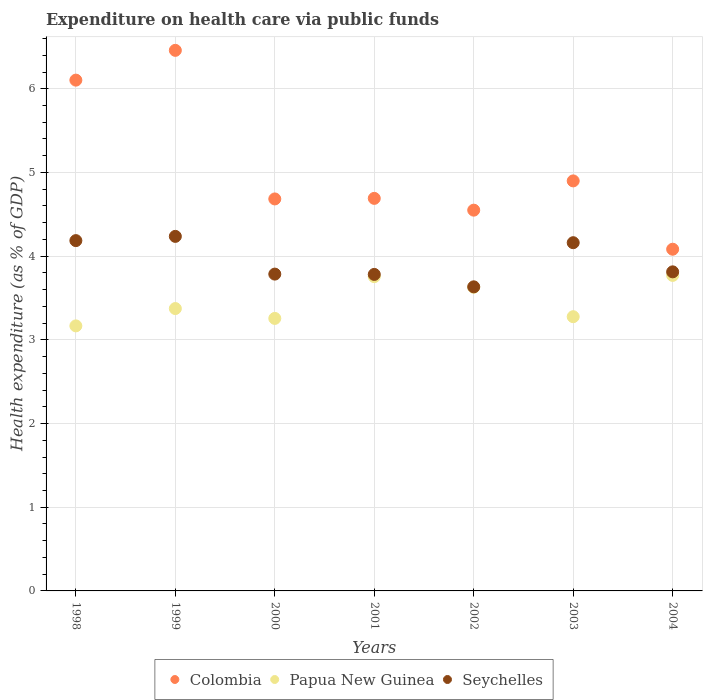How many different coloured dotlines are there?
Your response must be concise. 3. What is the expenditure made on health care in Papua New Guinea in 2004?
Your response must be concise. 3.77. Across all years, what is the maximum expenditure made on health care in Papua New Guinea?
Offer a very short reply. 3.77. Across all years, what is the minimum expenditure made on health care in Colombia?
Keep it short and to the point. 4.08. What is the total expenditure made on health care in Papua New Guinea in the graph?
Your response must be concise. 24.23. What is the difference between the expenditure made on health care in Papua New Guinea in 2002 and that in 2003?
Provide a succinct answer. 0.35. What is the difference between the expenditure made on health care in Papua New Guinea in 2003 and the expenditure made on health care in Colombia in 1999?
Your answer should be compact. -3.18. What is the average expenditure made on health care in Colombia per year?
Your answer should be compact. 5.07. In the year 2003, what is the difference between the expenditure made on health care in Papua New Guinea and expenditure made on health care in Colombia?
Your answer should be very brief. -1.62. In how many years, is the expenditure made on health care in Papua New Guinea greater than 3.8 %?
Your answer should be compact. 0. What is the ratio of the expenditure made on health care in Seychelles in 1999 to that in 2001?
Give a very brief answer. 1.12. What is the difference between the highest and the second highest expenditure made on health care in Seychelles?
Ensure brevity in your answer.  0.05. What is the difference between the highest and the lowest expenditure made on health care in Papua New Guinea?
Provide a short and direct response. 0.6. Is the sum of the expenditure made on health care in Papua New Guinea in 1998 and 2002 greater than the maximum expenditure made on health care in Seychelles across all years?
Keep it short and to the point. Yes. Is it the case that in every year, the sum of the expenditure made on health care in Colombia and expenditure made on health care in Papua New Guinea  is greater than the expenditure made on health care in Seychelles?
Your answer should be very brief. Yes. Is the expenditure made on health care in Papua New Guinea strictly less than the expenditure made on health care in Colombia over the years?
Your response must be concise. Yes. How many dotlines are there?
Your answer should be compact. 3. What is the difference between two consecutive major ticks on the Y-axis?
Make the answer very short. 1. Are the values on the major ticks of Y-axis written in scientific E-notation?
Make the answer very short. No. How are the legend labels stacked?
Provide a succinct answer. Horizontal. What is the title of the graph?
Make the answer very short. Expenditure on health care via public funds. What is the label or title of the X-axis?
Ensure brevity in your answer.  Years. What is the label or title of the Y-axis?
Provide a succinct answer. Health expenditure (as % of GDP). What is the Health expenditure (as % of GDP) of Colombia in 1998?
Ensure brevity in your answer.  6.1. What is the Health expenditure (as % of GDP) in Papua New Guinea in 1998?
Provide a short and direct response. 3.17. What is the Health expenditure (as % of GDP) of Seychelles in 1998?
Keep it short and to the point. 4.19. What is the Health expenditure (as % of GDP) in Colombia in 1999?
Offer a terse response. 6.46. What is the Health expenditure (as % of GDP) of Papua New Guinea in 1999?
Offer a terse response. 3.37. What is the Health expenditure (as % of GDP) in Seychelles in 1999?
Your response must be concise. 4.24. What is the Health expenditure (as % of GDP) of Colombia in 2000?
Keep it short and to the point. 4.68. What is the Health expenditure (as % of GDP) in Papua New Guinea in 2000?
Keep it short and to the point. 3.26. What is the Health expenditure (as % of GDP) in Seychelles in 2000?
Your answer should be compact. 3.79. What is the Health expenditure (as % of GDP) of Colombia in 2001?
Keep it short and to the point. 4.69. What is the Health expenditure (as % of GDP) of Papua New Guinea in 2001?
Provide a short and direct response. 3.76. What is the Health expenditure (as % of GDP) of Seychelles in 2001?
Your answer should be compact. 3.78. What is the Health expenditure (as % of GDP) in Colombia in 2002?
Make the answer very short. 4.55. What is the Health expenditure (as % of GDP) in Papua New Guinea in 2002?
Keep it short and to the point. 3.63. What is the Health expenditure (as % of GDP) of Seychelles in 2002?
Your response must be concise. 3.63. What is the Health expenditure (as % of GDP) in Colombia in 2003?
Your answer should be very brief. 4.9. What is the Health expenditure (as % of GDP) in Papua New Guinea in 2003?
Provide a succinct answer. 3.28. What is the Health expenditure (as % of GDP) in Seychelles in 2003?
Provide a succinct answer. 4.16. What is the Health expenditure (as % of GDP) of Colombia in 2004?
Your response must be concise. 4.08. What is the Health expenditure (as % of GDP) in Papua New Guinea in 2004?
Make the answer very short. 3.77. What is the Health expenditure (as % of GDP) of Seychelles in 2004?
Keep it short and to the point. 3.81. Across all years, what is the maximum Health expenditure (as % of GDP) of Colombia?
Ensure brevity in your answer.  6.46. Across all years, what is the maximum Health expenditure (as % of GDP) in Papua New Guinea?
Your response must be concise. 3.77. Across all years, what is the maximum Health expenditure (as % of GDP) of Seychelles?
Give a very brief answer. 4.24. Across all years, what is the minimum Health expenditure (as % of GDP) of Colombia?
Ensure brevity in your answer.  4.08. Across all years, what is the minimum Health expenditure (as % of GDP) of Papua New Guinea?
Provide a succinct answer. 3.17. Across all years, what is the minimum Health expenditure (as % of GDP) of Seychelles?
Provide a succinct answer. 3.63. What is the total Health expenditure (as % of GDP) in Colombia in the graph?
Provide a short and direct response. 35.47. What is the total Health expenditure (as % of GDP) in Papua New Guinea in the graph?
Your response must be concise. 24.23. What is the total Health expenditure (as % of GDP) of Seychelles in the graph?
Provide a short and direct response. 27.6. What is the difference between the Health expenditure (as % of GDP) in Colombia in 1998 and that in 1999?
Offer a very short reply. -0.36. What is the difference between the Health expenditure (as % of GDP) in Papua New Guinea in 1998 and that in 1999?
Your answer should be compact. -0.21. What is the difference between the Health expenditure (as % of GDP) in Seychelles in 1998 and that in 1999?
Give a very brief answer. -0.05. What is the difference between the Health expenditure (as % of GDP) of Colombia in 1998 and that in 2000?
Make the answer very short. 1.42. What is the difference between the Health expenditure (as % of GDP) of Papua New Guinea in 1998 and that in 2000?
Provide a succinct answer. -0.09. What is the difference between the Health expenditure (as % of GDP) of Seychelles in 1998 and that in 2000?
Your answer should be compact. 0.4. What is the difference between the Health expenditure (as % of GDP) of Colombia in 1998 and that in 2001?
Make the answer very short. 1.41. What is the difference between the Health expenditure (as % of GDP) of Papua New Guinea in 1998 and that in 2001?
Provide a succinct answer. -0.59. What is the difference between the Health expenditure (as % of GDP) of Seychelles in 1998 and that in 2001?
Your answer should be very brief. 0.4. What is the difference between the Health expenditure (as % of GDP) of Colombia in 1998 and that in 2002?
Make the answer very short. 1.55. What is the difference between the Health expenditure (as % of GDP) of Papua New Guinea in 1998 and that in 2002?
Provide a short and direct response. -0.46. What is the difference between the Health expenditure (as % of GDP) in Seychelles in 1998 and that in 2002?
Ensure brevity in your answer.  0.55. What is the difference between the Health expenditure (as % of GDP) of Colombia in 1998 and that in 2003?
Provide a short and direct response. 1.2. What is the difference between the Health expenditure (as % of GDP) in Papua New Guinea in 1998 and that in 2003?
Your response must be concise. -0.11. What is the difference between the Health expenditure (as % of GDP) of Seychelles in 1998 and that in 2003?
Your response must be concise. 0.02. What is the difference between the Health expenditure (as % of GDP) of Colombia in 1998 and that in 2004?
Your answer should be very brief. 2.02. What is the difference between the Health expenditure (as % of GDP) of Papua New Guinea in 1998 and that in 2004?
Your answer should be compact. -0.6. What is the difference between the Health expenditure (as % of GDP) in Seychelles in 1998 and that in 2004?
Provide a short and direct response. 0.37. What is the difference between the Health expenditure (as % of GDP) of Colombia in 1999 and that in 2000?
Your answer should be compact. 1.78. What is the difference between the Health expenditure (as % of GDP) in Papua New Guinea in 1999 and that in 2000?
Your answer should be compact. 0.12. What is the difference between the Health expenditure (as % of GDP) in Seychelles in 1999 and that in 2000?
Offer a terse response. 0.45. What is the difference between the Health expenditure (as % of GDP) of Colombia in 1999 and that in 2001?
Your response must be concise. 1.77. What is the difference between the Health expenditure (as % of GDP) in Papua New Guinea in 1999 and that in 2001?
Offer a terse response. -0.38. What is the difference between the Health expenditure (as % of GDP) in Seychelles in 1999 and that in 2001?
Your answer should be compact. 0.45. What is the difference between the Health expenditure (as % of GDP) of Colombia in 1999 and that in 2002?
Offer a very short reply. 1.91. What is the difference between the Health expenditure (as % of GDP) in Papua New Guinea in 1999 and that in 2002?
Keep it short and to the point. -0.25. What is the difference between the Health expenditure (as % of GDP) in Seychelles in 1999 and that in 2002?
Keep it short and to the point. 0.6. What is the difference between the Health expenditure (as % of GDP) in Colombia in 1999 and that in 2003?
Your answer should be very brief. 1.56. What is the difference between the Health expenditure (as % of GDP) of Papua New Guinea in 1999 and that in 2003?
Offer a terse response. 0.1. What is the difference between the Health expenditure (as % of GDP) of Seychelles in 1999 and that in 2003?
Give a very brief answer. 0.08. What is the difference between the Health expenditure (as % of GDP) in Colombia in 1999 and that in 2004?
Make the answer very short. 2.38. What is the difference between the Health expenditure (as % of GDP) in Papua New Guinea in 1999 and that in 2004?
Keep it short and to the point. -0.4. What is the difference between the Health expenditure (as % of GDP) of Seychelles in 1999 and that in 2004?
Ensure brevity in your answer.  0.42. What is the difference between the Health expenditure (as % of GDP) in Colombia in 2000 and that in 2001?
Provide a succinct answer. -0.01. What is the difference between the Health expenditure (as % of GDP) in Papua New Guinea in 2000 and that in 2001?
Provide a short and direct response. -0.5. What is the difference between the Health expenditure (as % of GDP) of Seychelles in 2000 and that in 2001?
Your response must be concise. 0. What is the difference between the Health expenditure (as % of GDP) of Colombia in 2000 and that in 2002?
Offer a very short reply. 0.13. What is the difference between the Health expenditure (as % of GDP) of Papua New Guinea in 2000 and that in 2002?
Offer a terse response. -0.37. What is the difference between the Health expenditure (as % of GDP) in Seychelles in 2000 and that in 2002?
Provide a short and direct response. 0.15. What is the difference between the Health expenditure (as % of GDP) of Colombia in 2000 and that in 2003?
Offer a very short reply. -0.22. What is the difference between the Health expenditure (as % of GDP) in Papua New Guinea in 2000 and that in 2003?
Provide a short and direct response. -0.02. What is the difference between the Health expenditure (as % of GDP) in Seychelles in 2000 and that in 2003?
Offer a terse response. -0.38. What is the difference between the Health expenditure (as % of GDP) of Colombia in 2000 and that in 2004?
Ensure brevity in your answer.  0.6. What is the difference between the Health expenditure (as % of GDP) of Papua New Guinea in 2000 and that in 2004?
Your answer should be compact. -0.51. What is the difference between the Health expenditure (as % of GDP) in Seychelles in 2000 and that in 2004?
Keep it short and to the point. -0.03. What is the difference between the Health expenditure (as % of GDP) of Colombia in 2001 and that in 2002?
Your response must be concise. 0.14. What is the difference between the Health expenditure (as % of GDP) in Papua New Guinea in 2001 and that in 2002?
Your answer should be very brief. 0.13. What is the difference between the Health expenditure (as % of GDP) in Seychelles in 2001 and that in 2002?
Provide a short and direct response. 0.15. What is the difference between the Health expenditure (as % of GDP) of Colombia in 2001 and that in 2003?
Your answer should be compact. -0.21. What is the difference between the Health expenditure (as % of GDP) of Papua New Guinea in 2001 and that in 2003?
Your response must be concise. 0.48. What is the difference between the Health expenditure (as % of GDP) in Seychelles in 2001 and that in 2003?
Give a very brief answer. -0.38. What is the difference between the Health expenditure (as % of GDP) of Colombia in 2001 and that in 2004?
Provide a succinct answer. 0.61. What is the difference between the Health expenditure (as % of GDP) in Papua New Guinea in 2001 and that in 2004?
Your answer should be compact. -0.01. What is the difference between the Health expenditure (as % of GDP) of Seychelles in 2001 and that in 2004?
Keep it short and to the point. -0.03. What is the difference between the Health expenditure (as % of GDP) of Colombia in 2002 and that in 2003?
Your answer should be compact. -0.35. What is the difference between the Health expenditure (as % of GDP) in Papua New Guinea in 2002 and that in 2003?
Offer a terse response. 0.35. What is the difference between the Health expenditure (as % of GDP) in Seychelles in 2002 and that in 2003?
Provide a short and direct response. -0.53. What is the difference between the Health expenditure (as % of GDP) in Colombia in 2002 and that in 2004?
Offer a terse response. 0.47. What is the difference between the Health expenditure (as % of GDP) in Papua New Guinea in 2002 and that in 2004?
Your response must be concise. -0.14. What is the difference between the Health expenditure (as % of GDP) in Seychelles in 2002 and that in 2004?
Provide a succinct answer. -0.18. What is the difference between the Health expenditure (as % of GDP) in Colombia in 2003 and that in 2004?
Provide a short and direct response. 0.82. What is the difference between the Health expenditure (as % of GDP) of Papua New Guinea in 2003 and that in 2004?
Keep it short and to the point. -0.49. What is the difference between the Health expenditure (as % of GDP) of Seychelles in 2003 and that in 2004?
Provide a short and direct response. 0.35. What is the difference between the Health expenditure (as % of GDP) of Colombia in 1998 and the Health expenditure (as % of GDP) of Papua New Guinea in 1999?
Offer a terse response. 2.73. What is the difference between the Health expenditure (as % of GDP) of Colombia in 1998 and the Health expenditure (as % of GDP) of Seychelles in 1999?
Offer a terse response. 1.87. What is the difference between the Health expenditure (as % of GDP) of Papua New Guinea in 1998 and the Health expenditure (as % of GDP) of Seychelles in 1999?
Provide a succinct answer. -1.07. What is the difference between the Health expenditure (as % of GDP) in Colombia in 1998 and the Health expenditure (as % of GDP) in Papua New Guinea in 2000?
Offer a very short reply. 2.85. What is the difference between the Health expenditure (as % of GDP) of Colombia in 1998 and the Health expenditure (as % of GDP) of Seychelles in 2000?
Provide a succinct answer. 2.32. What is the difference between the Health expenditure (as % of GDP) of Papua New Guinea in 1998 and the Health expenditure (as % of GDP) of Seychelles in 2000?
Offer a terse response. -0.62. What is the difference between the Health expenditure (as % of GDP) in Colombia in 1998 and the Health expenditure (as % of GDP) in Papua New Guinea in 2001?
Give a very brief answer. 2.35. What is the difference between the Health expenditure (as % of GDP) of Colombia in 1998 and the Health expenditure (as % of GDP) of Seychelles in 2001?
Offer a terse response. 2.32. What is the difference between the Health expenditure (as % of GDP) of Papua New Guinea in 1998 and the Health expenditure (as % of GDP) of Seychelles in 2001?
Ensure brevity in your answer.  -0.61. What is the difference between the Health expenditure (as % of GDP) in Colombia in 1998 and the Health expenditure (as % of GDP) in Papua New Guinea in 2002?
Ensure brevity in your answer.  2.48. What is the difference between the Health expenditure (as % of GDP) in Colombia in 1998 and the Health expenditure (as % of GDP) in Seychelles in 2002?
Ensure brevity in your answer.  2.47. What is the difference between the Health expenditure (as % of GDP) in Papua New Guinea in 1998 and the Health expenditure (as % of GDP) in Seychelles in 2002?
Your response must be concise. -0.47. What is the difference between the Health expenditure (as % of GDP) of Colombia in 1998 and the Health expenditure (as % of GDP) of Papua New Guinea in 2003?
Make the answer very short. 2.83. What is the difference between the Health expenditure (as % of GDP) in Colombia in 1998 and the Health expenditure (as % of GDP) in Seychelles in 2003?
Provide a short and direct response. 1.94. What is the difference between the Health expenditure (as % of GDP) in Papua New Guinea in 1998 and the Health expenditure (as % of GDP) in Seychelles in 2003?
Your answer should be very brief. -0.99. What is the difference between the Health expenditure (as % of GDP) of Colombia in 1998 and the Health expenditure (as % of GDP) of Papua New Guinea in 2004?
Ensure brevity in your answer.  2.33. What is the difference between the Health expenditure (as % of GDP) of Colombia in 1998 and the Health expenditure (as % of GDP) of Seychelles in 2004?
Ensure brevity in your answer.  2.29. What is the difference between the Health expenditure (as % of GDP) of Papua New Guinea in 1998 and the Health expenditure (as % of GDP) of Seychelles in 2004?
Offer a very short reply. -0.65. What is the difference between the Health expenditure (as % of GDP) in Colombia in 1999 and the Health expenditure (as % of GDP) in Papua New Guinea in 2000?
Make the answer very short. 3.2. What is the difference between the Health expenditure (as % of GDP) of Colombia in 1999 and the Health expenditure (as % of GDP) of Seychelles in 2000?
Your response must be concise. 2.67. What is the difference between the Health expenditure (as % of GDP) in Papua New Guinea in 1999 and the Health expenditure (as % of GDP) in Seychelles in 2000?
Offer a terse response. -0.41. What is the difference between the Health expenditure (as % of GDP) of Colombia in 1999 and the Health expenditure (as % of GDP) of Papua New Guinea in 2001?
Your answer should be very brief. 2.7. What is the difference between the Health expenditure (as % of GDP) of Colombia in 1999 and the Health expenditure (as % of GDP) of Seychelles in 2001?
Offer a very short reply. 2.68. What is the difference between the Health expenditure (as % of GDP) of Papua New Guinea in 1999 and the Health expenditure (as % of GDP) of Seychelles in 2001?
Give a very brief answer. -0.41. What is the difference between the Health expenditure (as % of GDP) in Colombia in 1999 and the Health expenditure (as % of GDP) in Papua New Guinea in 2002?
Your response must be concise. 2.83. What is the difference between the Health expenditure (as % of GDP) in Colombia in 1999 and the Health expenditure (as % of GDP) in Seychelles in 2002?
Make the answer very short. 2.83. What is the difference between the Health expenditure (as % of GDP) in Papua New Guinea in 1999 and the Health expenditure (as % of GDP) in Seychelles in 2002?
Offer a very short reply. -0.26. What is the difference between the Health expenditure (as % of GDP) in Colombia in 1999 and the Health expenditure (as % of GDP) in Papua New Guinea in 2003?
Make the answer very short. 3.18. What is the difference between the Health expenditure (as % of GDP) in Colombia in 1999 and the Health expenditure (as % of GDP) in Seychelles in 2003?
Your answer should be very brief. 2.3. What is the difference between the Health expenditure (as % of GDP) of Papua New Guinea in 1999 and the Health expenditure (as % of GDP) of Seychelles in 2003?
Provide a succinct answer. -0.79. What is the difference between the Health expenditure (as % of GDP) of Colombia in 1999 and the Health expenditure (as % of GDP) of Papua New Guinea in 2004?
Give a very brief answer. 2.69. What is the difference between the Health expenditure (as % of GDP) in Colombia in 1999 and the Health expenditure (as % of GDP) in Seychelles in 2004?
Give a very brief answer. 2.65. What is the difference between the Health expenditure (as % of GDP) in Papua New Guinea in 1999 and the Health expenditure (as % of GDP) in Seychelles in 2004?
Offer a terse response. -0.44. What is the difference between the Health expenditure (as % of GDP) of Colombia in 2000 and the Health expenditure (as % of GDP) of Papua New Guinea in 2001?
Your answer should be very brief. 0.93. What is the difference between the Health expenditure (as % of GDP) of Colombia in 2000 and the Health expenditure (as % of GDP) of Seychelles in 2001?
Keep it short and to the point. 0.9. What is the difference between the Health expenditure (as % of GDP) of Papua New Guinea in 2000 and the Health expenditure (as % of GDP) of Seychelles in 2001?
Your response must be concise. -0.53. What is the difference between the Health expenditure (as % of GDP) of Colombia in 2000 and the Health expenditure (as % of GDP) of Papua New Guinea in 2002?
Offer a terse response. 1.06. What is the difference between the Health expenditure (as % of GDP) of Colombia in 2000 and the Health expenditure (as % of GDP) of Seychelles in 2002?
Keep it short and to the point. 1.05. What is the difference between the Health expenditure (as % of GDP) of Papua New Guinea in 2000 and the Health expenditure (as % of GDP) of Seychelles in 2002?
Ensure brevity in your answer.  -0.38. What is the difference between the Health expenditure (as % of GDP) of Colombia in 2000 and the Health expenditure (as % of GDP) of Papua New Guinea in 2003?
Make the answer very short. 1.41. What is the difference between the Health expenditure (as % of GDP) of Colombia in 2000 and the Health expenditure (as % of GDP) of Seychelles in 2003?
Your answer should be compact. 0.52. What is the difference between the Health expenditure (as % of GDP) in Papua New Guinea in 2000 and the Health expenditure (as % of GDP) in Seychelles in 2003?
Your answer should be very brief. -0.9. What is the difference between the Health expenditure (as % of GDP) in Colombia in 2000 and the Health expenditure (as % of GDP) in Papua New Guinea in 2004?
Your answer should be compact. 0.91. What is the difference between the Health expenditure (as % of GDP) of Colombia in 2000 and the Health expenditure (as % of GDP) of Seychelles in 2004?
Offer a terse response. 0.87. What is the difference between the Health expenditure (as % of GDP) in Papua New Guinea in 2000 and the Health expenditure (as % of GDP) in Seychelles in 2004?
Make the answer very short. -0.56. What is the difference between the Health expenditure (as % of GDP) of Colombia in 2001 and the Health expenditure (as % of GDP) of Papua New Guinea in 2002?
Offer a very short reply. 1.06. What is the difference between the Health expenditure (as % of GDP) of Colombia in 2001 and the Health expenditure (as % of GDP) of Seychelles in 2002?
Keep it short and to the point. 1.06. What is the difference between the Health expenditure (as % of GDP) of Papua New Guinea in 2001 and the Health expenditure (as % of GDP) of Seychelles in 2002?
Keep it short and to the point. 0.12. What is the difference between the Health expenditure (as % of GDP) of Colombia in 2001 and the Health expenditure (as % of GDP) of Papua New Guinea in 2003?
Keep it short and to the point. 1.41. What is the difference between the Health expenditure (as % of GDP) of Colombia in 2001 and the Health expenditure (as % of GDP) of Seychelles in 2003?
Your answer should be very brief. 0.53. What is the difference between the Health expenditure (as % of GDP) in Papua New Guinea in 2001 and the Health expenditure (as % of GDP) in Seychelles in 2003?
Your answer should be compact. -0.41. What is the difference between the Health expenditure (as % of GDP) of Colombia in 2001 and the Health expenditure (as % of GDP) of Papua New Guinea in 2004?
Offer a terse response. 0.92. What is the difference between the Health expenditure (as % of GDP) of Colombia in 2001 and the Health expenditure (as % of GDP) of Seychelles in 2004?
Keep it short and to the point. 0.88. What is the difference between the Health expenditure (as % of GDP) in Papua New Guinea in 2001 and the Health expenditure (as % of GDP) in Seychelles in 2004?
Ensure brevity in your answer.  -0.06. What is the difference between the Health expenditure (as % of GDP) of Colombia in 2002 and the Health expenditure (as % of GDP) of Papua New Guinea in 2003?
Keep it short and to the point. 1.27. What is the difference between the Health expenditure (as % of GDP) of Colombia in 2002 and the Health expenditure (as % of GDP) of Seychelles in 2003?
Your answer should be compact. 0.39. What is the difference between the Health expenditure (as % of GDP) in Papua New Guinea in 2002 and the Health expenditure (as % of GDP) in Seychelles in 2003?
Provide a short and direct response. -0.53. What is the difference between the Health expenditure (as % of GDP) in Colombia in 2002 and the Health expenditure (as % of GDP) in Papua New Guinea in 2004?
Give a very brief answer. 0.78. What is the difference between the Health expenditure (as % of GDP) in Colombia in 2002 and the Health expenditure (as % of GDP) in Seychelles in 2004?
Offer a very short reply. 0.74. What is the difference between the Health expenditure (as % of GDP) in Papua New Guinea in 2002 and the Health expenditure (as % of GDP) in Seychelles in 2004?
Your answer should be very brief. -0.18. What is the difference between the Health expenditure (as % of GDP) in Colombia in 2003 and the Health expenditure (as % of GDP) in Papua New Guinea in 2004?
Give a very brief answer. 1.13. What is the difference between the Health expenditure (as % of GDP) in Colombia in 2003 and the Health expenditure (as % of GDP) in Seychelles in 2004?
Your response must be concise. 1.09. What is the difference between the Health expenditure (as % of GDP) of Papua New Guinea in 2003 and the Health expenditure (as % of GDP) of Seychelles in 2004?
Your answer should be compact. -0.54. What is the average Health expenditure (as % of GDP) of Colombia per year?
Provide a succinct answer. 5.07. What is the average Health expenditure (as % of GDP) of Papua New Guinea per year?
Give a very brief answer. 3.46. What is the average Health expenditure (as % of GDP) of Seychelles per year?
Offer a very short reply. 3.94. In the year 1998, what is the difference between the Health expenditure (as % of GDP) in Colombia and Health expenditure (as % of GDP) in Papua New Guinea?
Provide a succinct answer. 2.94. In the year 1998, what is the difference between the Health expenditure (as % of GDP) of Colombia and Health expenditure (as % of GDP) of Seychelles?
Provide a short and direct response. 1.92. In the year 1998, what is the difference between the Health expenditure (as % of GDP) of Papua New Guinea and Health expenditure (as % of GDP) of Seychelles?
Offer a terse response. -1.02. In the year 1999, what is the difference between the Health expenditure (as % of GDP) of Colombia and Health expenditure (as % of GDP) of Papua New Guinea?
Your answer should be compact. 3.09. In the year 1999, what is the difference between the Health expenditure (as % of GDP) in Colombia and Health expenditure (as % of GDP) in Seychelles?
Offer a terse response. 2.22. In the year 1999, what is the difference between the Health expenditure (as % of GDP) of Papua New Guinea and Health expenditure (as % of GDP) of Seychelles?
Your answer should be very brief. -0.86. In the year 2000, what is the difference between the Health expenditure (as % of GDP) of Colombia and Health expenditure (as % of GDP) of Papua New Guinea?
Ensure brevity in your answer.  1.43. In the year 2000, what is the difference between the Health expenditure (as % of GDP) in Colombia and Health expenditure (as % of GDP) in Seychelles?
Provide a short and direct response. 0.9. In the year 2000, what is the difference between the Health expenditure (as % of GDP) of Papua New Guinea and Health expenditure (as % of GDP) of Seychelles?
Offer a terse response. -0.53. In the year 2001, what is the difference between the Health expenditure (as % of GDP) of Colombia and Health expenditure (as % of GDP) of Papua New Guinea?
Ensure brevity in your answer.  0.94. In the year 2001, what is the difference between the Health expenditure (as % of GDP) of Colombia and Health expenditure (as % of GDP) of Seychelles?
Offer a terse response. 0.91. In the year 2001, what is the difference between the Health expenditure (as % of GDP) of Papua New Guinea and Health expenditure (as % of GDP) of Seychelles?
Your response must be concise. -0.03. In the year 2002, what is the difference between the Health expenditure (as % of GDP) of Colombia and Health expenditure (as % of GDP) of Papua New Guinea?
Ensure brevity in your answer.  0.92. In the year 2002, what is the difference between the Health expenditure (as % of GDP) of Colombia and Health expenditure (as % of GDP) of Seychelles?
Make the answer very short. 0.92. In the year 2002, what is the difference between the Health expenditure (as % of GDP) of Papua New Guinea and Health expenditure (as % of GDP) of Seychelles?
Your answer should be compact. -0.01. In the year 2003, what is the difference between the Health expenditure (as % of GDP) of Colombia and Health expenditure (as % of GDP) of Papua New Guinea?
Provide a succinct answer. 1.62. In the year 2003, what is the difference between the Health expenditure (as % of GDP) of Colombia and Health expenditure (as % of GDP) of Seychelles?
Give a very brief answer. 0.74. In the year 2003, what is the difference between the Health expenditure (as % of GDP) of Papua New Guinea and Health expenditure (as % of GDP) of Seychelles?
Your answer should be very brief. -0.88. In the year 2004, what is the difference between the Health expenditure (as % of GDP) of Colombia and Health expenditure (as % of GDP) of Papua New Guinea?
Your answer should be very brief. 0.31. In the year 2004, what is the difference between the Health expenditure (as % of GDP) in Colombia and Health expenditure (as % of GDP) in Seychelles?
Provide a succinct answer. 0.27. In the year 2004, what is the difference between the Health expenditure (as % of GDP) of Papua New Guinea and Health expenditure (as % of GDP) of Seychelles?
Your response must be concise. -0.04. What is the ratio of the Health expenditure (as % of GDP) in Colombia in 1998 to that in 1999?
Ensure brevity in your answer.  0.94. What is the ratio of the Health expenditure (as % of GDP) of Papua New Guinea in 1998 to that in 1999?
Make the answer very short. 0.94. What is the ratio of the Health expenditure (as % of GDP) in Seychelles in 1998 to that in 1999?
Your response must be concise. 0.99. What is the ratio of the Health expenditure (as % of GDP) of Colombia in 1998 to that in 2000?
Give a very brief answer. 1.3. What is the ratio of the Health expenditure (as % of GDP) in Papua New Guinea in 1998 to that in 2000?
Provide a short and direct response. 0.97. What is the ratio of the Health expenditure (as % of GDP) of Seychelles in 1998 to that in 2000?
Keep it short and to the point. 1.11. What is the ratio of the Health expenditure (as % of GDP) of Colombia in 1998 to that in 2001?
Make the answer very short. 1.3. What is the ratio of the Health expenditure (as % of GDP) in Papua New Guinea in 1998 to that in 2001?
Ensure brevity in your answer.  0.84. What is the ratio of the Health expenditure (as % of GDP) of Seychelles in 1998 to that in 2001?
Your answer should be very brief. 1.11. What is the ratio of the Health expenditure (as % of GDP) of Colombia in 1998 to that in 2002?
Provide a short and direct response. 1.34. What is the ratio of the Health expenditure (as % of GDP) of Papua New Guinea in 1998 to that in 2002?
Provide a succinct answer. 0.87. What is the ratio of the Health expenditure (as % of GDP) of Seychelles in 1998 to that in 2002?
Your answer should be compact. 1.15. What is the ratio of the Health expenditure (as % of GDP) of Colombia in 1998 to that in 2003?
Keep it short and to the point. 1.25. What is the ratio of the Health expenditure (as % of GDP) in Papua New Guinea in 1998 to that in 2003?
Ensure brevity in your answer.  0.97. What is the ratio of the Health expenditure (as % of GDP) of Seychelles in 1998 to that in 2003?
Make the answer very short. 1.01. What is the ratio of the Health expenditure (as % of GDP) of Colombia in 1998 to that in 2004?
Give a very brief answer. 1.49. What is the ratio of the Health expenditure (as % of GDP) in Papua New Guinea in 1998 to that in 2004?
Keep it short and to the point. 0.84. What is the ratio of the Health expenditure (as % of GDP) of Seychelles in 1998 to that in 2004?
Offer a terse response. 1.1. What is the ratio of the Health expenditure (as % of GDP) in Colombia in 1999 to that in 2000?
Provide a succinct answer. 1.38. What is the ratio of the Health expenditure (as % of GDP) of Papua New Guinea in 1999 to that in 2000?
Provide a succinct answer. 1.04. What is the ratio of the Health expenditure (as % of GDP) of Seychelles in 1999 to that in 2000?
Offer a terse response. 1.12. What is the ratio of the Health expenditure (as % of GDP) of Colombia in 1999 to that in 2001?
Offer a terse response. 1.38. What is the ratio of the Health expenditure (as % of GDP) in Papua New Guinea in 1999 to that in 2001?
Make the answer very short. 0.9. What is the ratio of the Health expenditure (as % of GDP) of Seychelles in 1999 to that in 2001?
Your answer should be compact. 1.12. What is the ratio of the Health expenditure (as % of GDP) in Colombia in 1999 to that in 2002?
Ensure brevity in your answer.  1.42. What is the ratio of the Health expenditure (as % of GDP) in Papua New Guinea in 1999 to that in 2002?
Offer a very short reply. 0.93. What is the ratio of the Health expenditure (as % of GDP) of Seychelles in 1999 to that in 2002?
Give a very brief answer. 1.17. What is the ratio of the Health expenditure (as % of GDP) in Colombia in 1999 to that in 2003?
Make the answer very short. 1.32. What is the ratio of the Health expenditure (as % of GDP) in Papua New Guinea in 1999 to that in 2003?
Provide a short and direct response. 1.03. What is the ratio of the Health expenditure (as % of GDP) of Seychelles in 1999 to that in 2003?
Keep it short and to the point. 1.02. What is the ratio of the Health expenditure (as % of GDP) in Colombia in 1999 to that in 2004?
Offer a very short reply. 1.58. What is the ratio of the Health expenditure (as % of GDP) of Papua New Guinea in 1999 to that in 2004?
Your response must be concise. 0.89. What is the ratio of the Health expenditure (as % of GDP) of Seychelles in 1999 to that in 2004?
Keep it short and to the point. 1.11. What is the ratio of the Health expenditure (as % of GDP) in Colombia in 2000 to that in 2001?
Ensure brevity in your answer.  1. What is the ratio of the Health expenditure (as % of GDP) of Papua New Guinea in 2000 to that in 2001?
Provide a short and direct response. 0.87. What is the ratio of the Health expenditure (as % of GDP) of Colombia in 2000 to that in 2002?
Offer a terse response. 1.03. What is the ratio of the Health expenditure (as % of GDP) of Papua New Guinea in 2000 to that in 2002?
Offer a very short reply. 0.9. What is the ratio of the Health expenditure (as % of GDP) of Seychelles in 2000 to that in 2002?
Your answer should be very brief. 1.04. What is the ratio of the Health expenditure (as % of GDP) in Colombia in 2000 to that in 2003?
Keep it short and to the point. 0.96. What is the ratio of the Health expenditure (as % of GDP) in Seychelles in 2000 to that in 2003?
Ensure brevity in your answer.  0.91. What is the ratio of the Health expenditure (as % of GDP) in Colombia in 2000 to that in 2004?
Offer a terse response. 1.15. What is the ratio of the Health expenditure (as % of GDP) in Papua New Guinea in 2000 to that in 2004?
Your answer should be compact. 0.86. What is the ratio of the Health expenditure (as % of GDP) in Colombia in 2001 to that in 2002?
Keep it short and to the point. 1.03. What is the ratio of the Health expenditure (as % of GDP) of Papua New Guinea in 2001 to that in 2002?
Your response must be concise. 1.03. What is the ratio of the Health expenditure (as % of GDP) in Seychelles in 2001 to that in 2002?
Offer a very short reply. 1.04. What is the ratio of the Health expenditure (as % of GDP) of Colombia in 2001 to that in 2003?
Your answer should be very brief. 0.96. What is the ratio of the Health expenditure (as % of GDP) in Papua New Guinea in 2001 to that in 2003?
Keep it short and to the point. 1.15. What is the ratio of the Health expenditure (as % of GDP) of Seychelles in 2001 to that in 2003?
Your answer should be compact. 0.91. What is the ratio of the Health expenditure (as % of GDP) in Colombia in 2001 to that in 2004?
Offer a terse response. 1.15. What is the ratio of the Health expenditure (as % of GDP) of Seychelles in 2001 to that in 2004?
Your response must be concise. 0.99. What is the ratio of the Health expenditure (as % of GDP) of Colombia in 2002 to that in 2003?
Give a very brief answer. 0.93. What is the ratio of the Health expenditure (as % of GDP) of Papua New Guinea in 2002 to that in 2003?
Provide a short and direct response. 1.11. What is the ratio of the Health expenditure (as % of GDP) in Seychelles in 2002 to that in 2003?
Your response must be concise. 0.87. What is the ratio of the Health expenditure (as % of GDP) in Colombia in 2002 to that in 2004?
Make the answer very short. 1.11. What is the ratio of the Health expenditure (as % of GDP) of Papua New Guinea in 2002 to that in 2004?
Provide a succinct answer. 0.96. What is the ratio of the Health expenditure (as % of GDP) of Seychelles in 2002 to that in 2004?
Provide a short and direct response. 0.95. What is the ratio of the Health expenditure (as % of GDP) in Papua New Guinea in 2003 to that in 2004?
Offer a very short reply. 0.87. What is the ratio of the Health expenditure (as % of GDP) in Seychelles in 2003 to that in 2004?
Offer a very short reply. 1.09. What is the difference between the highest and the second highest Health expenditure (as % of GDP) of Colombia?
Provide a short and direct response. 0.36. What is the difference between the highest and the second highest Health expenditure (as % of GDP) in Papua New Guinea?
Provide a short and direct response. 0.01. What is the difference between the highest and the second highest Health expenditure (as % of GDP) in Seychelles?
Give a very brief answer. 0.05. What is the difference between the highest and the lowest Health expenditure (as % of GDP) in Colombia?
Your answer should be compact. 2.38. What is the difference between the highest and the lowest Health expenditure (as % of GDP) of Papua New Guinea?
Your answer should be compact. 0.6. What is the difference between the highest and the lowest Health expenditure (as % of GDP) in Seychelles?
Offer a terse response. 0.6. 